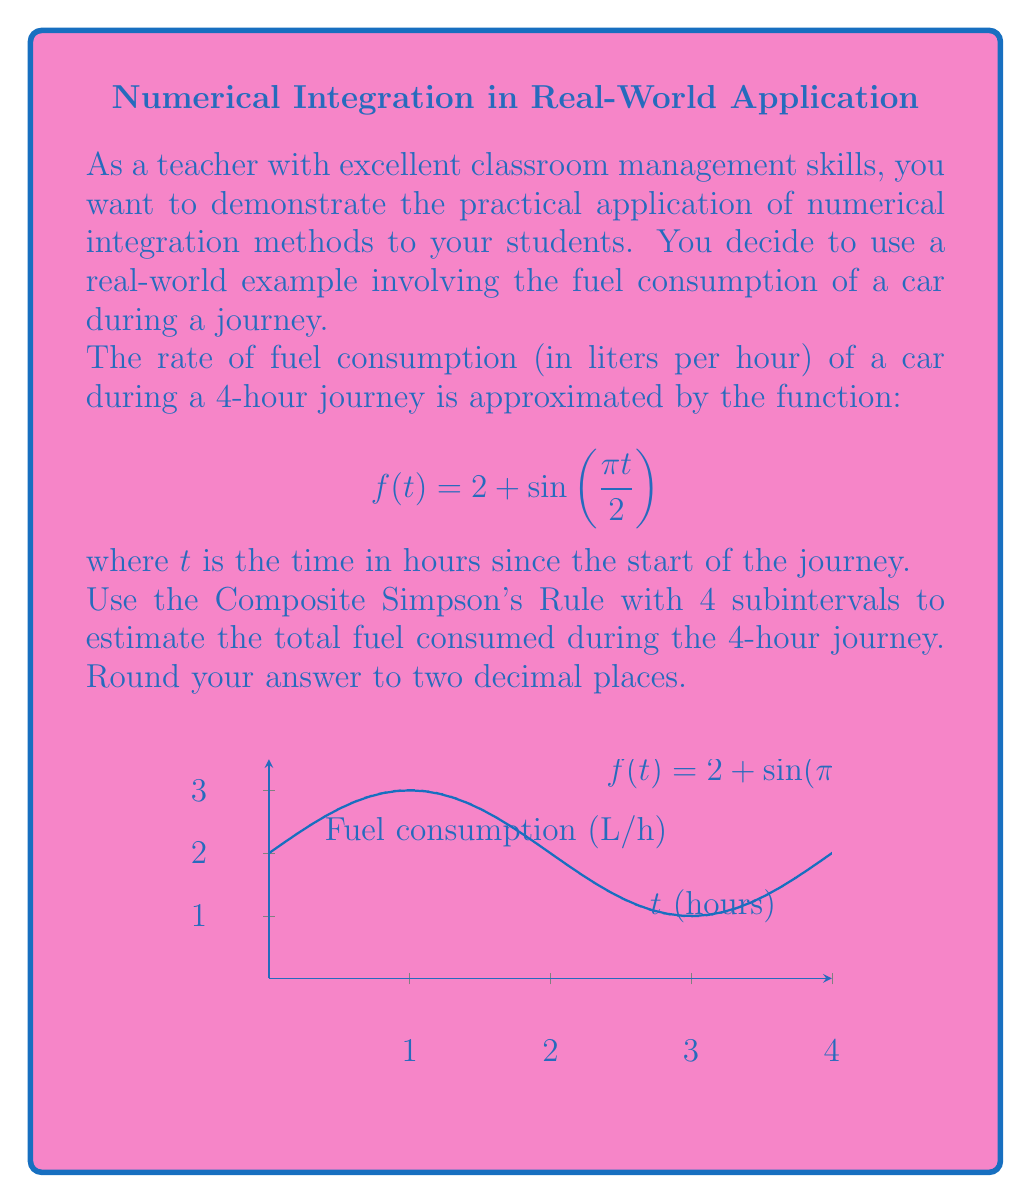Help me with this question. Let's approach this step-by-step using the Composite Simpson's Rule:

1) The Composite Simpson's Rule for n subintervals is given by:

   $$\int_a^b f(x)dx \approx \frac{h}{3}[f(x_0) + 4f(x_1) + 2f(x_2) + 4f(x_3) + f(x_4)]$$

   where $h = \frac{b-a}{n}$, and $x_i = a + ih$ for $i = 0, 1, 2, 3, 4$

2) In our case, $a=0$, $b=4$, and $n=4$. So, $h = \frac{4-0}{4} = 1$

3) We need to calculate $f(x_i)$ for $i = 0, 1, 2, 3, 4$:

   $f(x_0) = f(0) = 2 + \sin(0) = 2$
   $f(x_1) = f(1) = 2 + \sin(\frac{\pi}{2}) = 3$
   $f(x_2) = f(2) = 2 + \sin(\pi) = 2$
   $f(x_3) = f(3) = 2 + \sin(\frac{3\pi}{2}) = 1$
   $f(x_4) = f(4) = 2 + \sin(2\pi) = 2$

4) Now, let's substitute these values into the formula:

   $$\int_0^4 f(t)dt \approx \frac{1}{3}[2 + 4(3) + 2(2) + 4(1) + 2]$$

5) Simplify:

   $$\approx \frac{1}{3}[2 + 12 + 4 + 4 + 2] = \frac{24}{3} = 8$$

6) This result represents the total fuel consumed in liters over the 4-hour journey.
Answer: 8.00 liters 